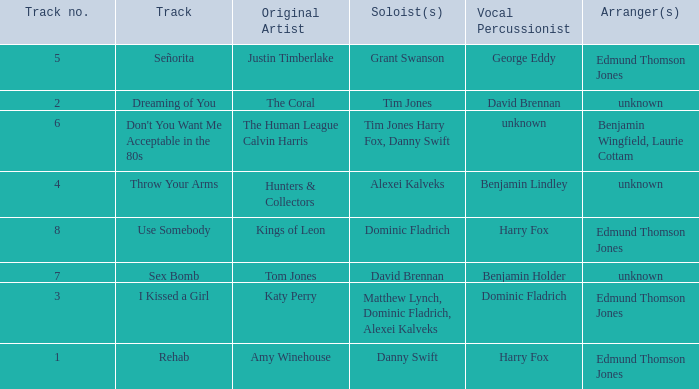Who is the original artist of "Use Somebody"? Kings of Leon. 